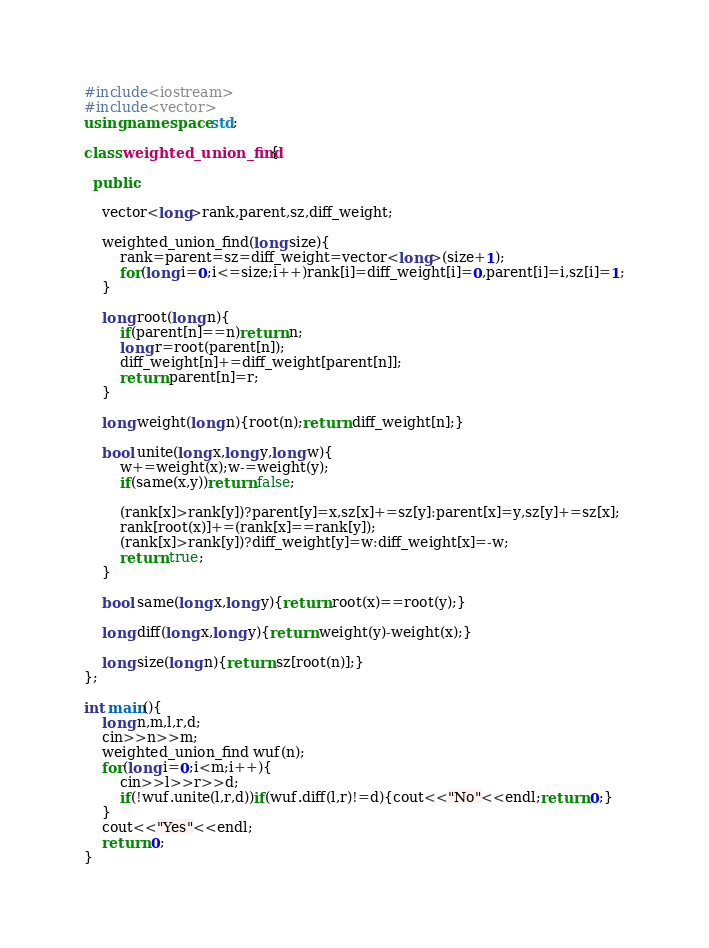<code> <loc_0><loc_0><loc_500><loc_500><_C++_>#include<iostream>
#include<vector>
using namespace std;

class weighted_union_find{

  public:

    vector<long>rank,parent,sz,diff_weight;

    weighted_union_find(long size){
        rank=parent=sz=diff_weight=vector<long>(size+1);
        for(long i=0;i<=size;i++)rank[i]=diff_weight[i]=0,parent[i]=i,sz[i]=1;
    }
    
    long root(long n){
        if(parent[n]==n)return n;
        long r=root(parent[n]);
        diff_weight[n]+=diff_weight[parent[n]];
        return parent[n]=r;
    }
    
    long weight(long n){root(n);return diff_weight[n];}

    bool unite(long x,long y,long w){
        w+=weight(x);w-=weight(y);
        if(same(x,y))return false;
      
        (rank[x]>rank[y])?parent[y]=x,sz[x]+=sz[y]:parent[x]=y,sz[y]+=sz[x];
        rank[root(x)]+=(rank[x]==rank[y]);
        (rank[x]>rank[y])?diff_weight[y]=w:diff_weight[x]=-w;
        return true;
    }
    
    bool same(long x,long y){return root(x)==root(y);}
    
    long diff(long x,long y){return weight(y)-weight(x);}

    long size(long n){return sz[root(n)];}
};

int main(){
    long n,m,l,r,d;
    cin>>n>>m;
    weighted_union_find wuf(n);
    for(long i=0;i<m;i++){
        cin>>l>>r>>d;
        if(!wuf.unite(l,r,d))if(wuf.diff(l,r)!=d){cout<<"No"<<endl;return 0;}
    }
    cout<<"Yes"<<endl;
    return 0;
}</code> 